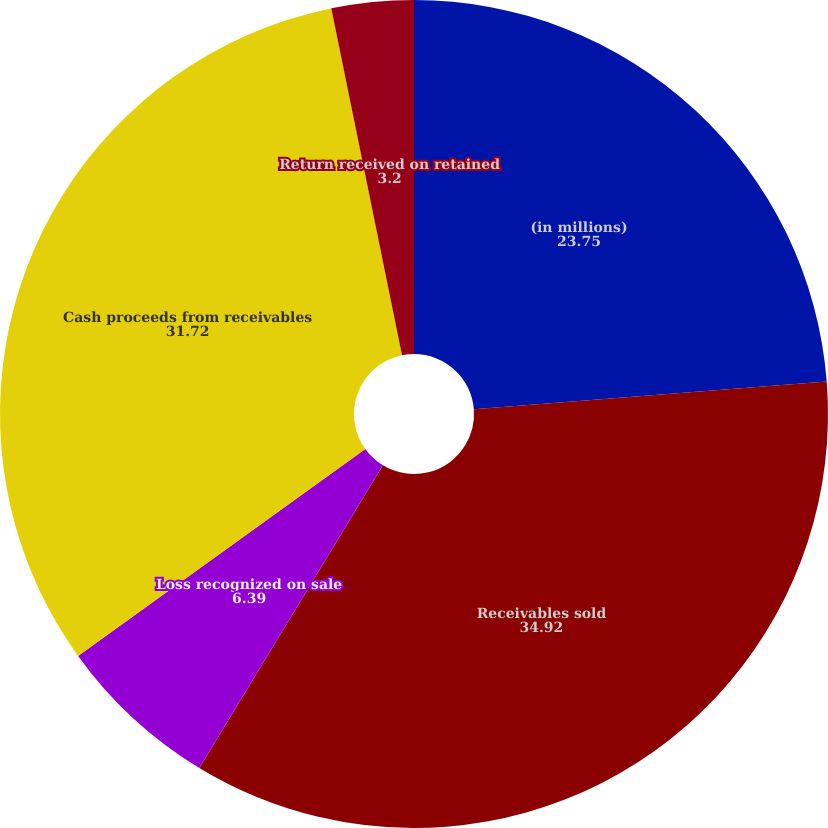<chart> <loc_0><loc_0><loc_500><loc_500><pie_chart><fcel>(in millions)<fcel>Receivables sold<fcel>Loss recognized on sale<fcel>Cash proceeds from receivables<fcel>Collection fees received<fcel>Return received on retained<nl><fcel>23.75%<fcel>34.92%<fcel>6.39%<fcel>31.72%<fcel>0.01%<fcel>3.2%<nl></chart> 